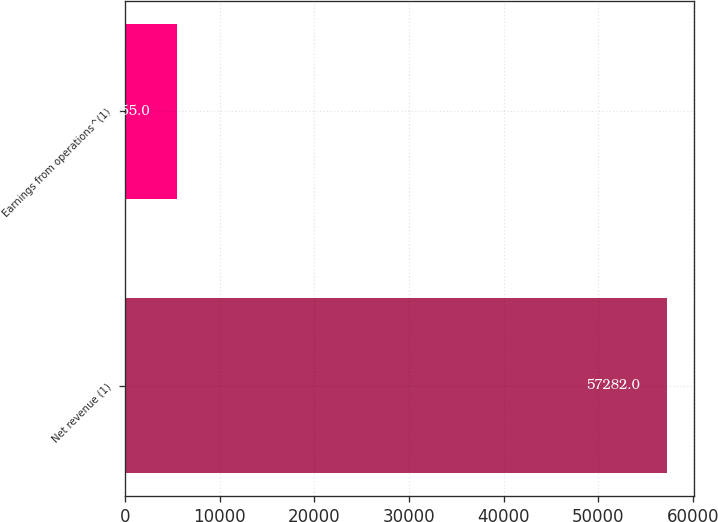<chart> <loc_0><loc_0><loc_500><loc_500><bar_chart><fcel>Net revenue (1)<fcel>Earnings from operations^(1)<nl><fcel>57282<fcel>5455<nl></chart> 